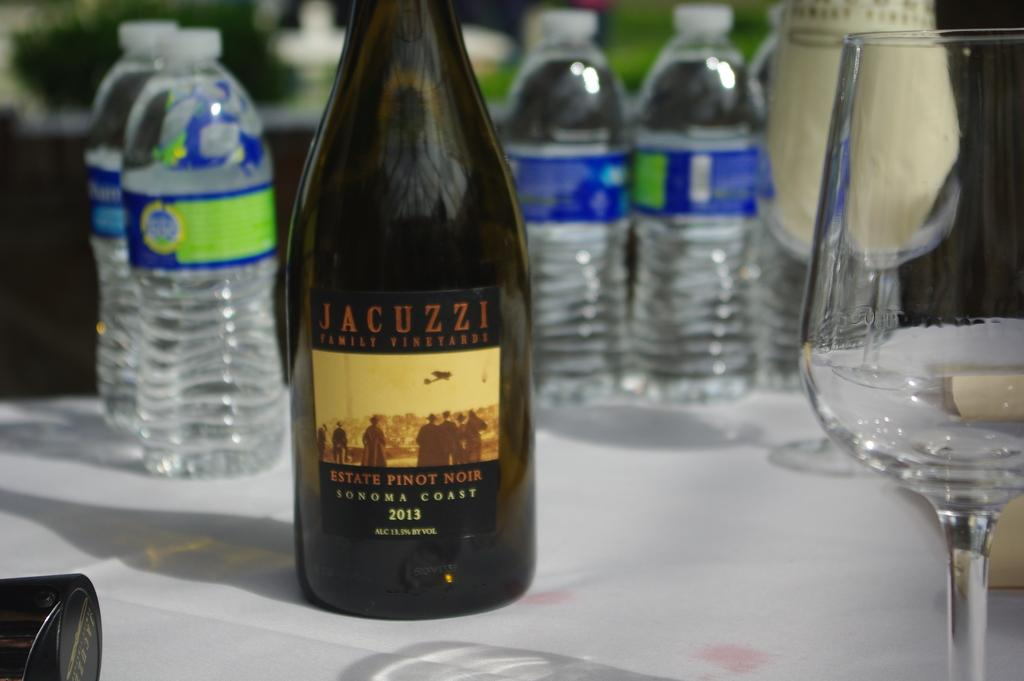<image>
Describe the image concisely. A bottle has the word jacuzzi on the label and bottles of water behind it. 